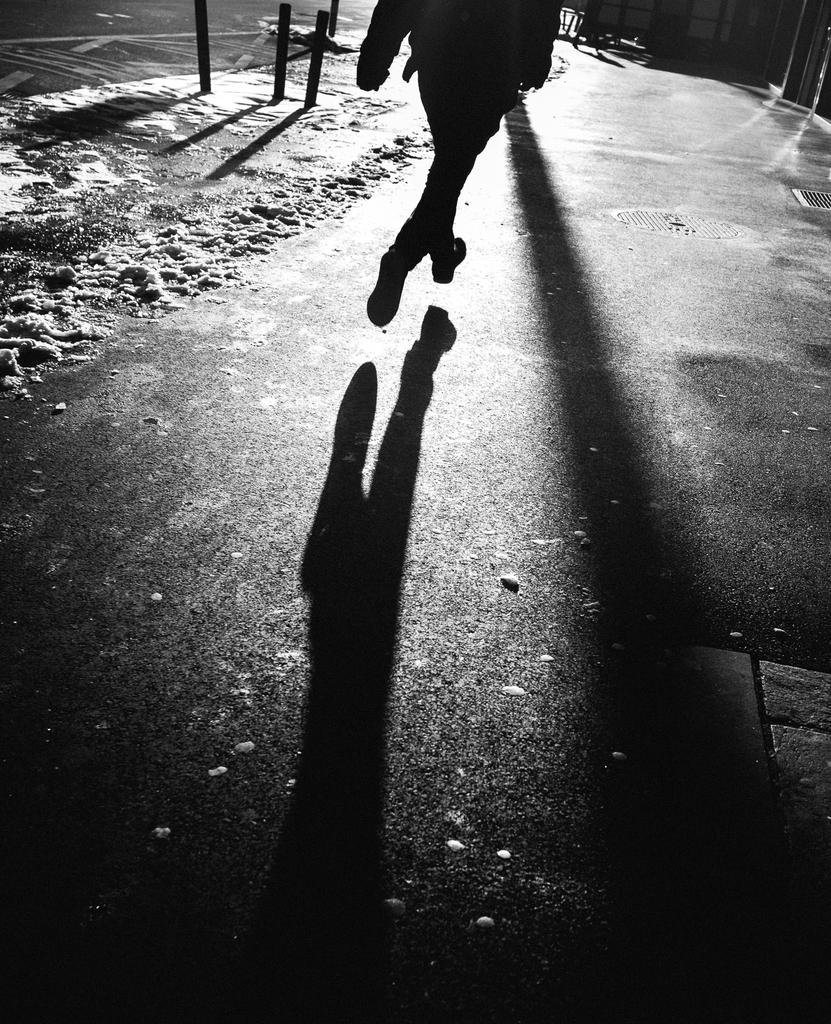What is the color scheme of the image? The image is black and white. Can you describe the main subject in the image? There is a person in the image. What objects are present in the image besides the person? There are poles in the image. What can be seen in the background of the image? There is sand and a wall visible in the background of the image. What type of muscle is being flexed by the person in the image? There is no indication of a muscle being flexed in the image, as it is in black and white and does not show any specific body movements. 